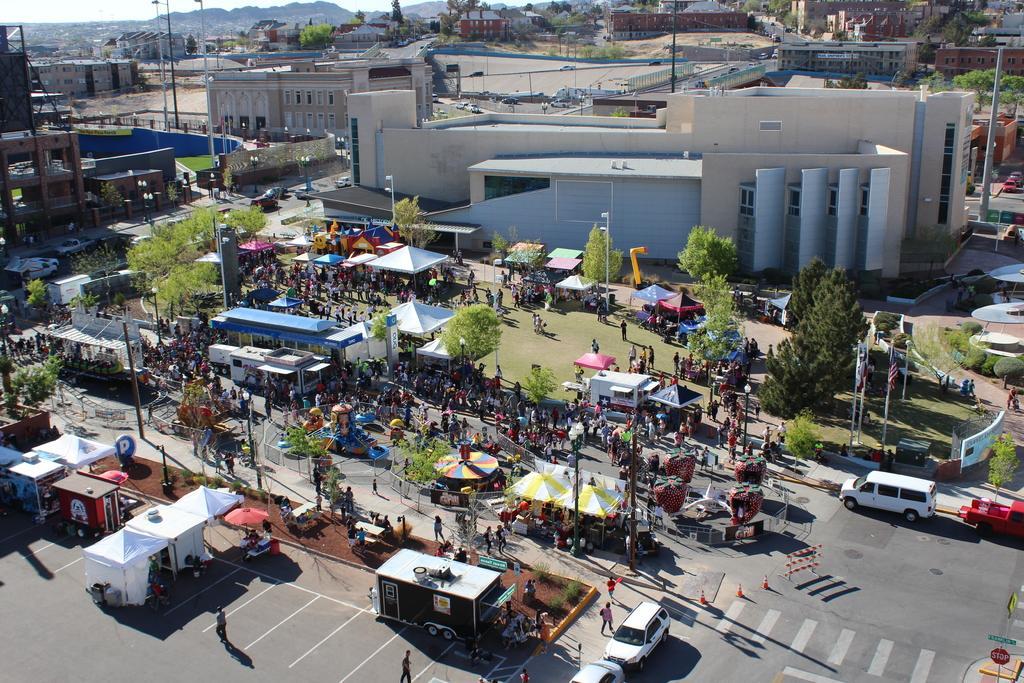How would you summarize this image in a sentence or two? This image is taken from the top, where we can see vehicles on the road, tents, shelters, persons, poles, trees, sign board, traffic cones on the road, flags, grass, buildings, roads, mountains and the sky. 